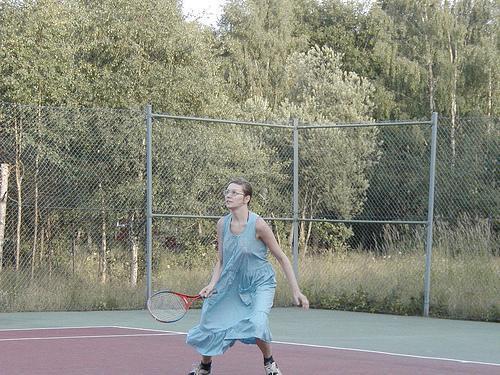How many people playing tennis?
Give a very brief answer. 1. 